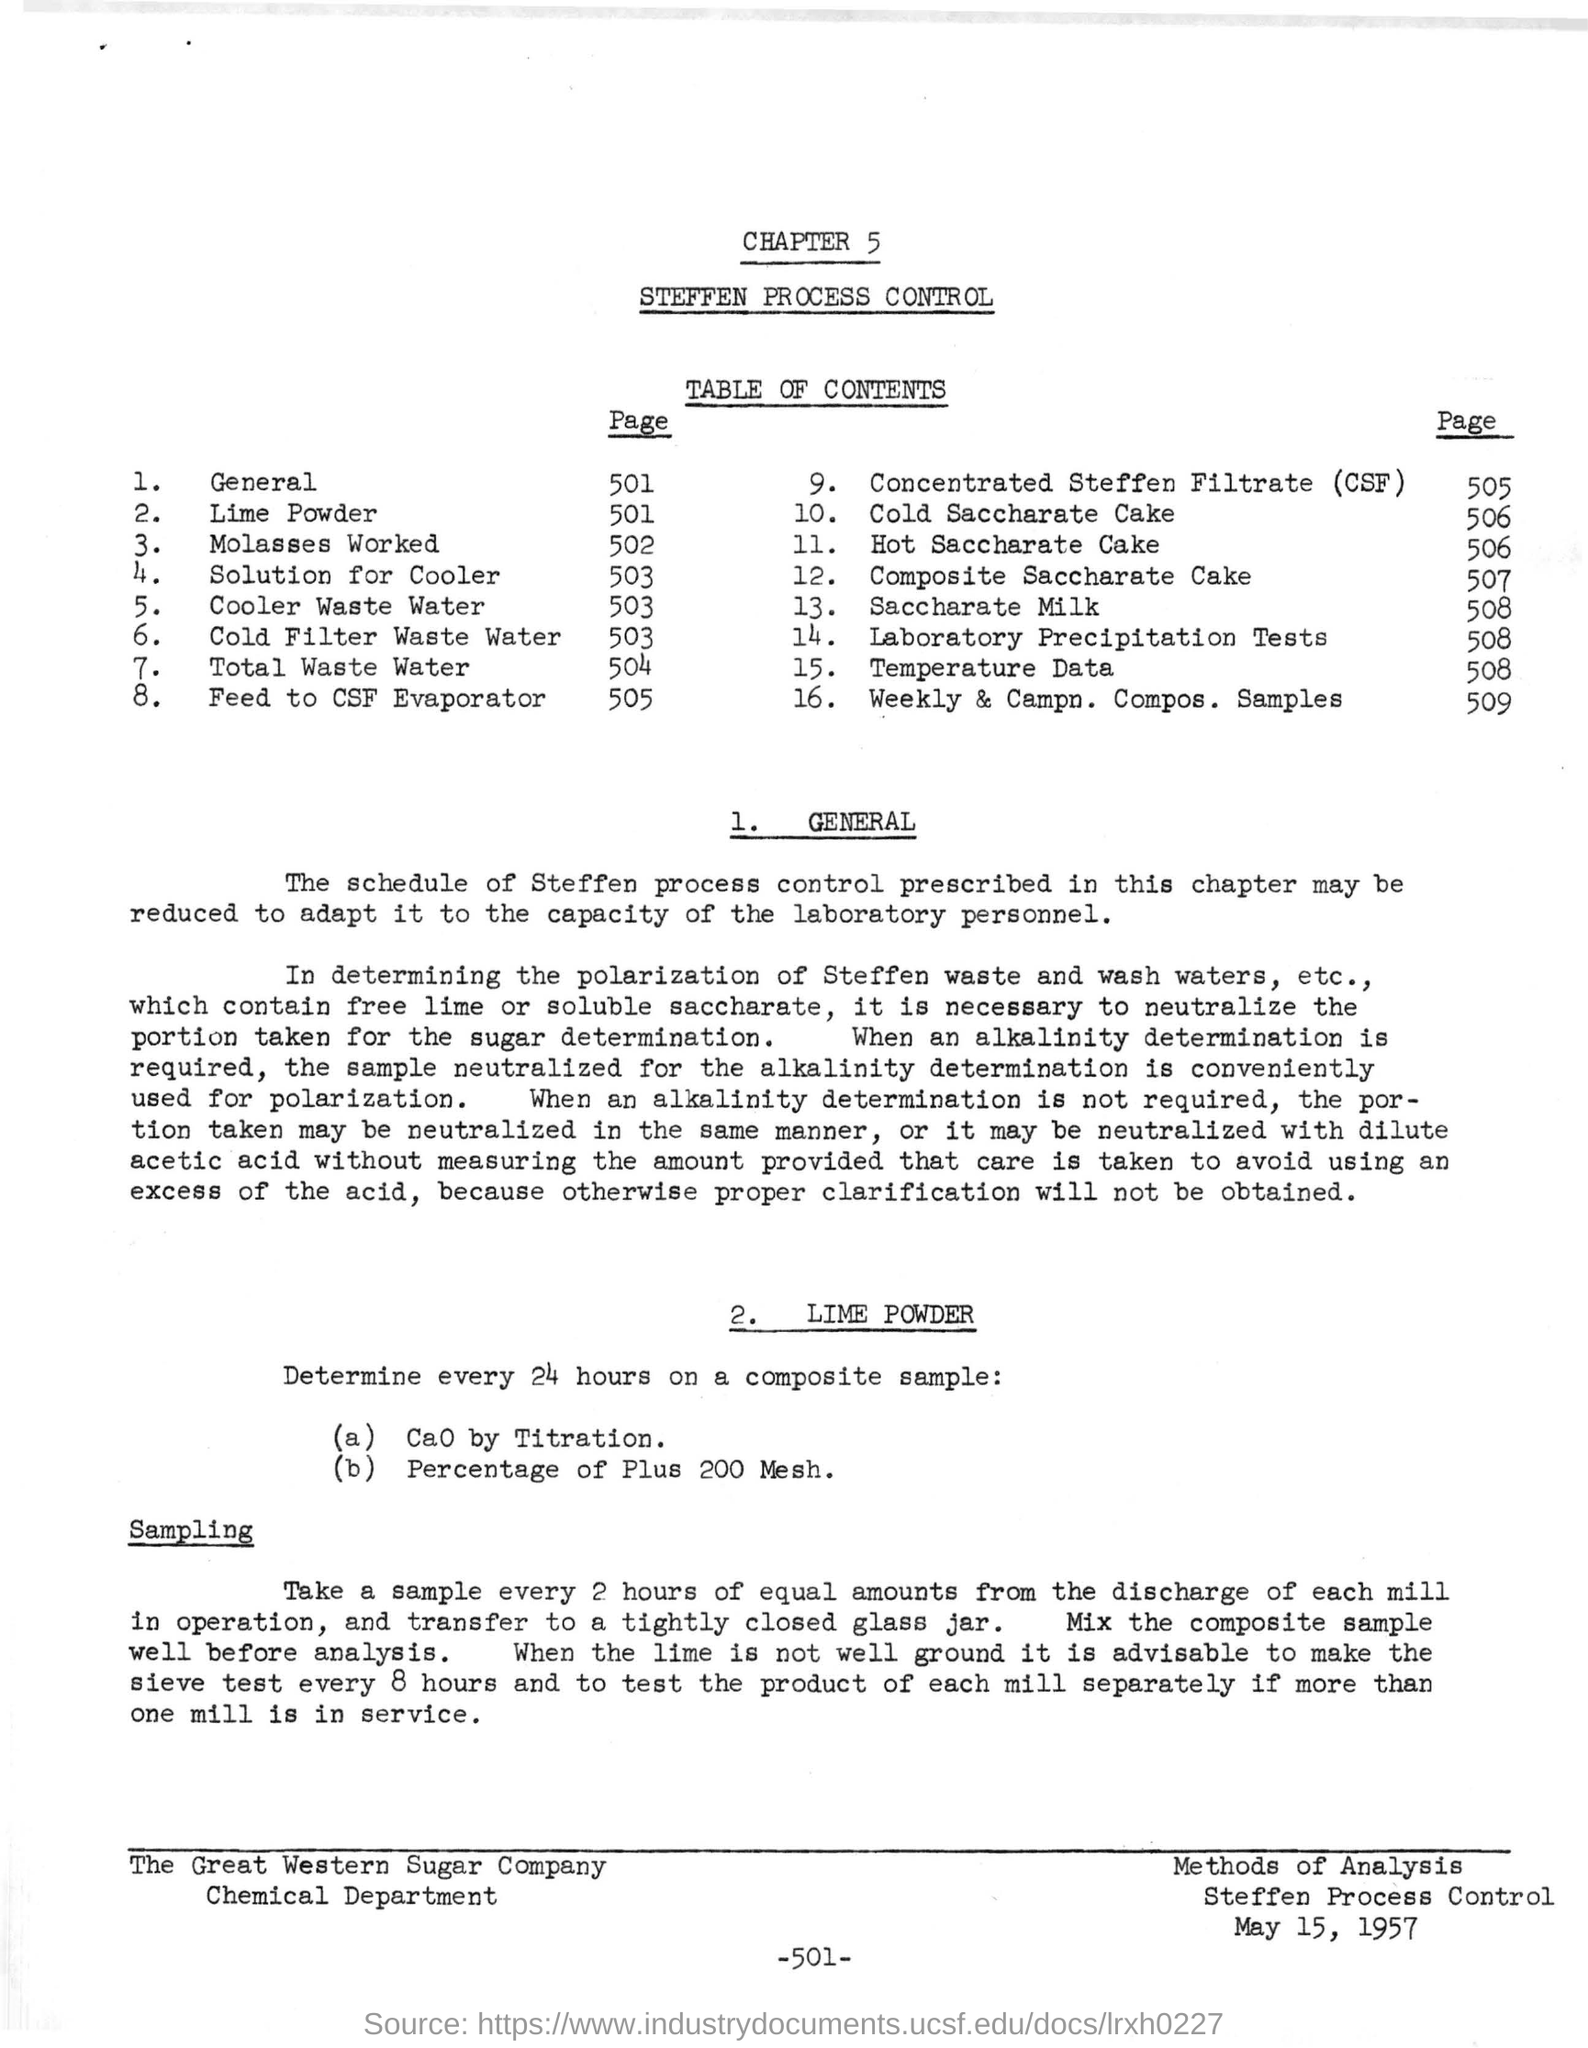Draw attention to some important aspects in this diagram. A composite sample should be analyzed every 24 hours to determine the concentration of calcium oxide (CaO) by titration, and the percentage of material with a particle size of 200 mesh or finer. The laboratory precipitation tests can be found on page 508. The document is dated May 15, 1957. The title of Chapter 5 is "Steffken Process Control." 